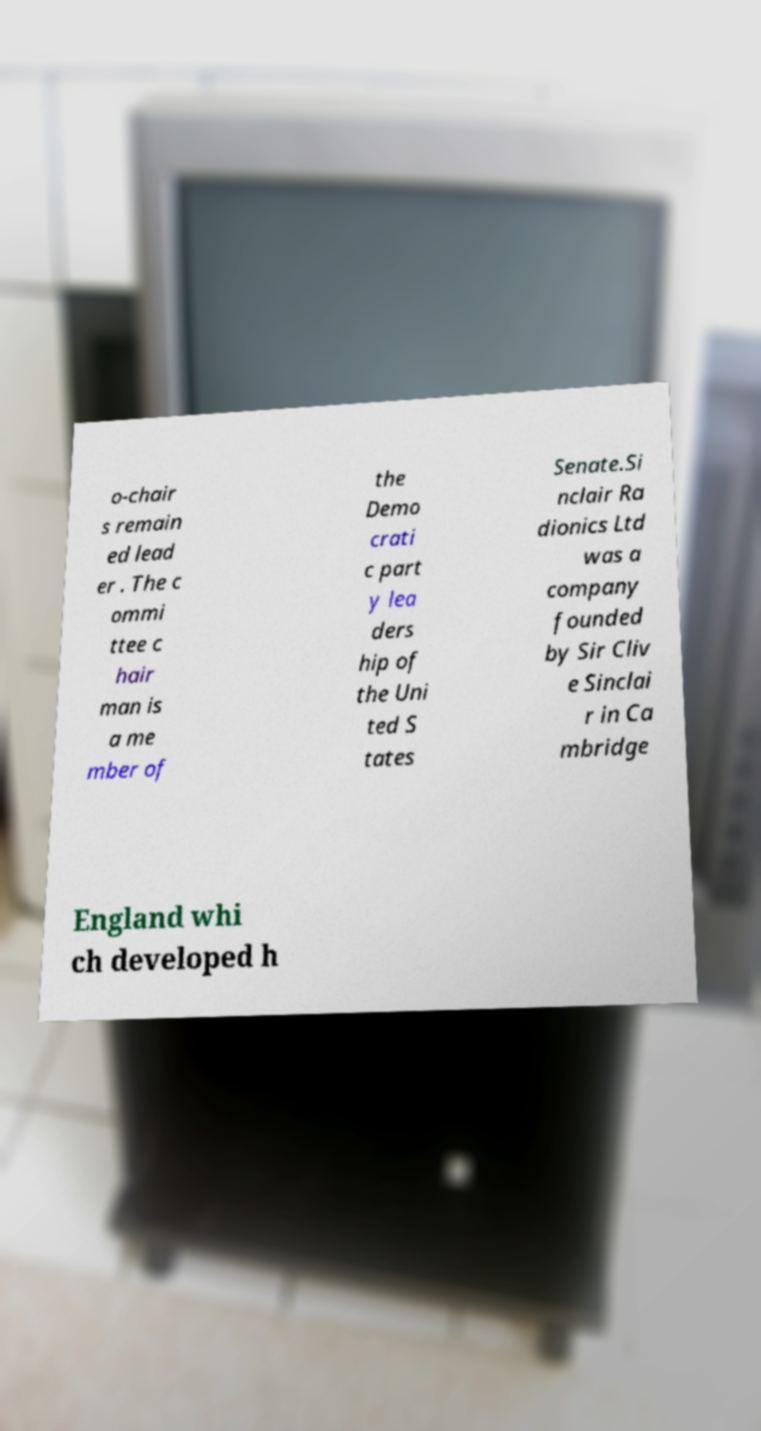Can you accurately transcribe the text from the provided image for me? o-chair s remain ed lead er . The c ommi ttee c hair man is a me mber of the Demo crati c part y lea ders hip of the Uni ted S tates Senate.Si nclair Ra dionics Ltd was a company founded by Sir Cliv e Sinclai r in Ca mbridge England whi ch developed h 